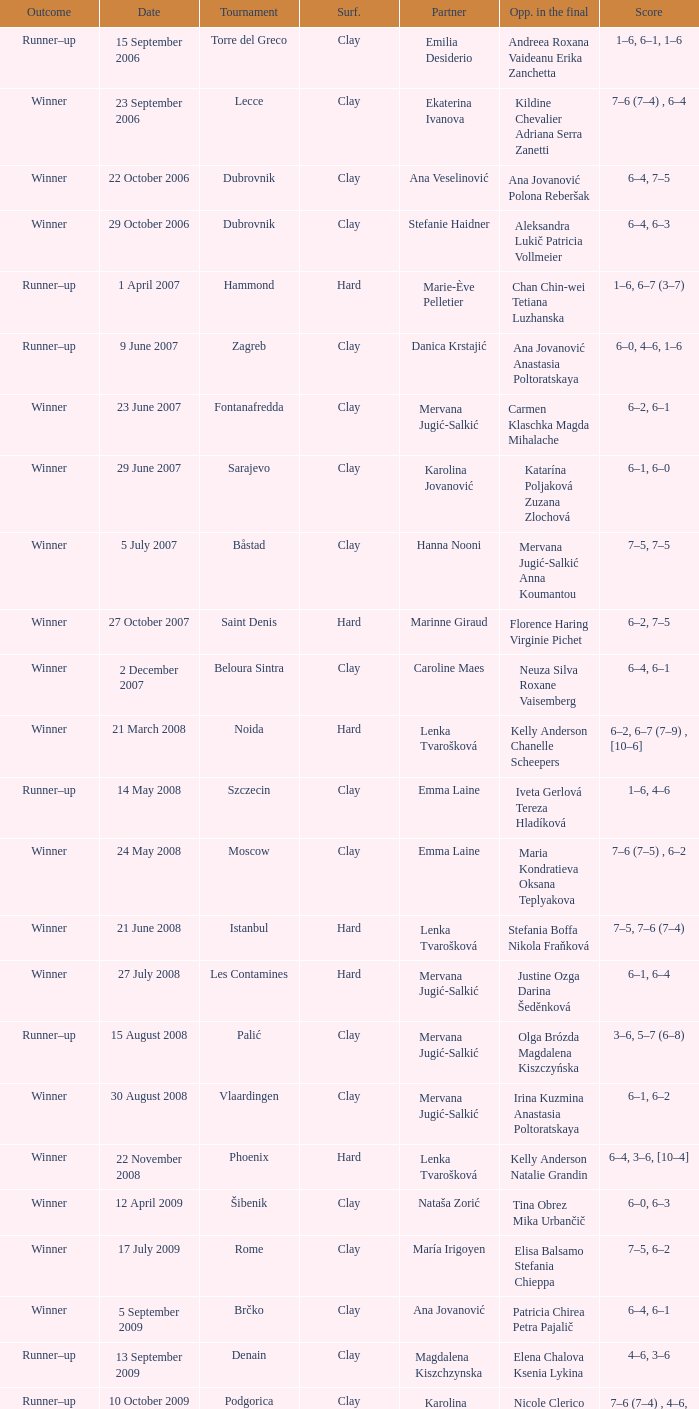Which tournament had a partner of Erika Sema? Aschaffenburg. 